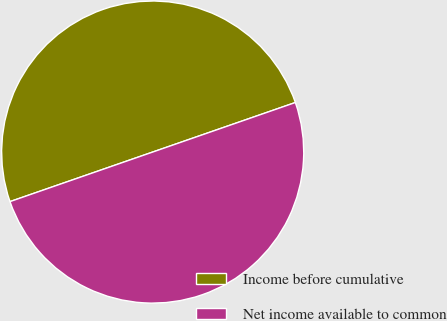Convert chart. <chart><loc_0><loc_0><loc_500><loc_500><pie_chart><fcel>Income before cumulative<fcel>Net income available to common<nl><fcel>50.0%<fcel>50.0%<nl></chart> 